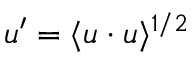<formula> <loc_0><loc_0><loc_500><loc_500>u ^ { \prime } = \langle u \cdot u \rangle ^ { 1 / 2 }</formula> 